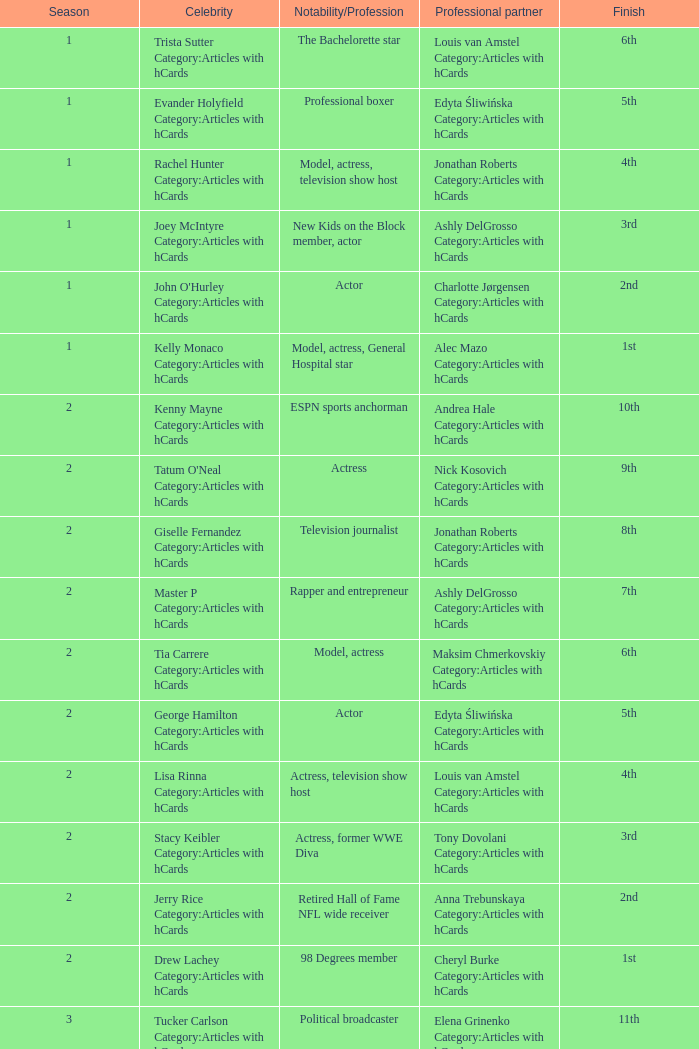What was the profession of the celebrity who was featured on season 15 and finished 7th place? Actress, comedian. 